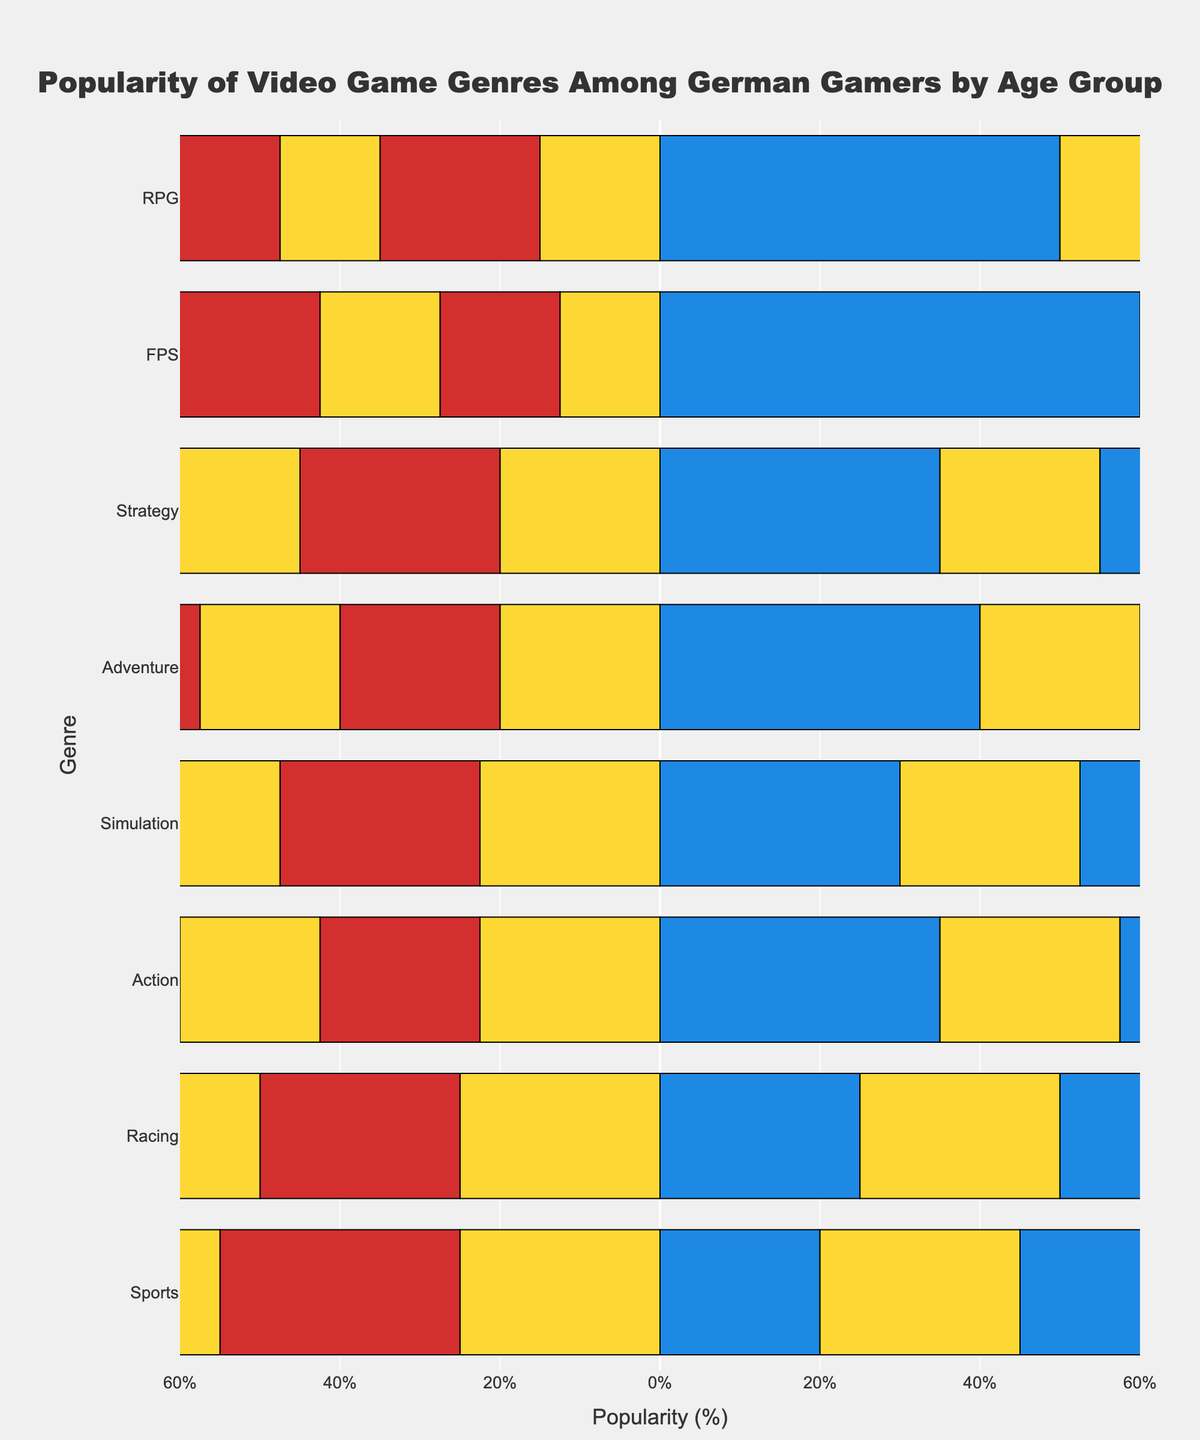What age group has the highest positive rating for the FPS genre? The positive ratings for FPS are 60% (18-24), 50% (25-34), 40% (35-44), and 30% (45-54). Hence, the highest positive rating is for the age group 18-24.
Answer: 18-24 Which genre has the greatest neutral rating for the 25-34 age group? By looking at the neutral ratings for the 25-34 age group, the highest is for Racing and Sports, both at 50%.
Answer: Racing and Sports In the 35-44 age group, which genre has the largest difference between positive and negative ratings? The difference between positive and negative ratings can be calculated for each genre in the 35-44 age group: Action (30-30=0), Adventure (35-25=10), RPG (45-20=25), FPS (40-25=15), Sports (20-30=-10), Racing (25-30=-5), Simulation (40-25=15), Strategy (45-25=20). RPG has the greatest difference of 25.
Answer: RPG Which genre and age group combination has the highest negative rating? The negative ratings are 30% or higher for Action (45-54), Sports (45-54) and Racing (45-54) at 40% and for Sports again at 45% (45-54). Hence, the highest negative rating is for the Sports genre in the 45-54 age group.
Answer: Sports (45-54) What age group has the lowest positive rating for the RPG genre? The positive ratings for RPG by age group are 50% (18-24), 55% (25-34), 45% (35-44), and 35% (45-54). Hence, the lowest positive rating is for the age group 45-54.
Answer: 45-54 How many genres have more than 40% positive ratings in the 25-34 age group? For the 25-34 age group, the genres with more than 40% positive ratings are Action (40%), Adventure (45%), RPG (55%), FPS (50%), and Strategy (40%). So there are 5 genres.
Answer: 5 Which genre in the 18-24 age group has the highest combined percentage of positive and neutral ratings? The combined positive and neutral ratings for the 18-24 age group are: Action (35+45=80), Adventure (40+40=80), RPG (50+30=80), FPS (60+25=85), Sports (20+50=70), Racing (25+50=75), Simulation (30+45=75), Strategy (35+40=75). FPS has the highest combined positive and neutral ratings of 85%.
Answer: FPS Which genre has a decreasing trend in positive ratings across all age groups? By comparing the positive ratings for each genre across age groups, Action (35, 40, 30, 20) shows a decreasing trend (35 > 40 > 30 > 20).
Answer: Action What is the average positive rating for the Adventure genre across all age groups? The positive ratings for Adventure are: 40% (18-24), 45% (25-34), 35% (35-44), and 25% (45-54). The average is (40+45+35+25)/4 = 36.25%.
Answer: 36.25 